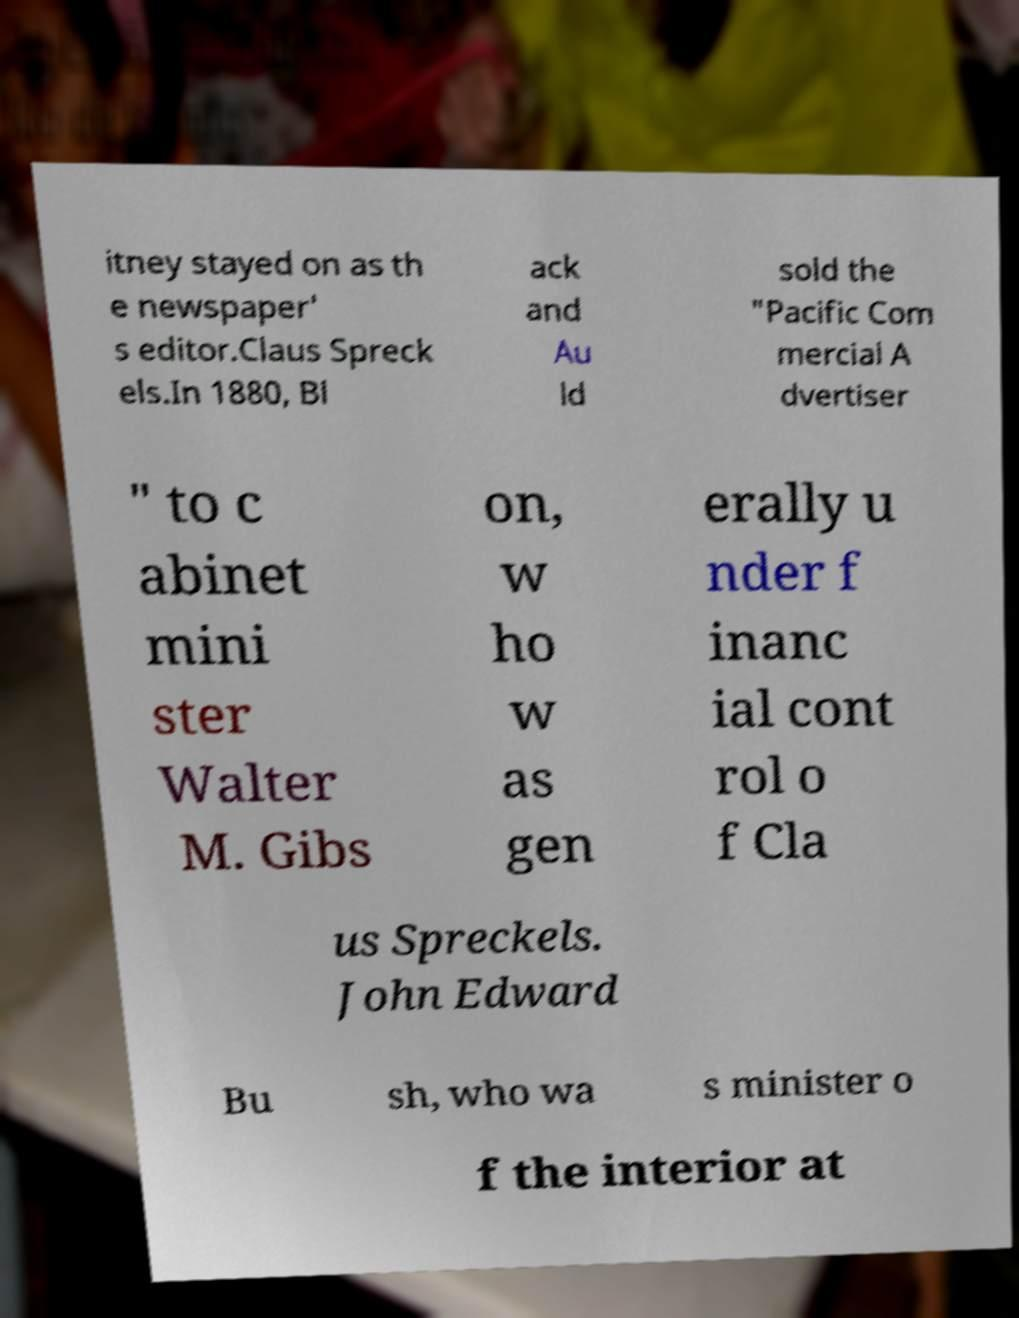Could you extract and type out the text from this image? itney stayed on as th e newspaper' s editor.Claus Spreck els.In 1880, Bl ack and Au ld sold the "Pacific Com mercial A dvertiser " to c abinet mini ster Walter M. Gibs on, w ho w as gen erally u nder f inanc ial cont rol o f Cla us Spreckels. John Edward Bu sh, who wa s minister o f the interior at 